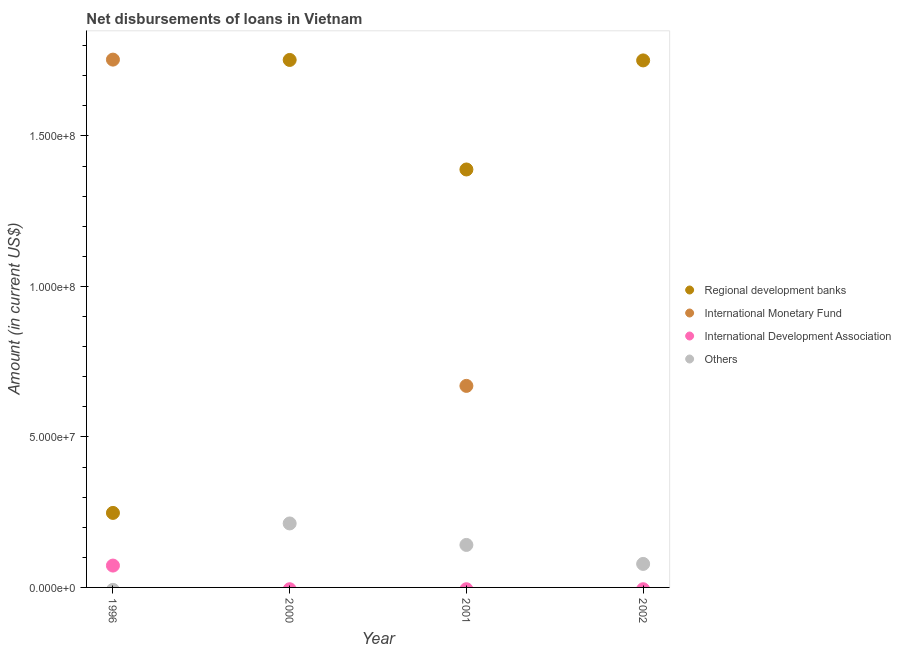How many different coloured dotlines are there?
Offer a very short reply. 4. Is the number of dotlines equal to the number of legend labels?
Give a very brief answer. No. What is the amount of loan disimbursed by international monetary fund in 2000?
Provide a short and direct response. 0. Across all years, what is the maximum amount of loan disimbursed by international monetary fund?
Ensure brevity in your answer.  1.75e+08. Across all years, what is the minimum amount of loan disimbursed by other organisations?
Ensure brevity in your answer.  0. What is the total amount of loan disimbursed by regional development banks in the graph?
Your answer should be compact. 5.14e+08. What is the difference between the amount of loan disimbursed by regional development banks in 1996 and that in 2000?
Offer a very short reply. -1.51e+08. What is the difference between the amount of loan disimbursed by international development association in 1996 and the amount of loan disimbursed by international monetary fund in 2000?
Keep it short and to the point. 7.26e+06. What is the average amount of loan disimbursed by international development association per year?
Keep it short and to the point. 1.82e+06. In the year 1996, what is the difference between the amount of loan disimbursed by regional development banks and amount of loan disimbursed by international development association?
Your response must be concise. 1.75e+07. What is the ratio of the amount of loan disimbursed by regional development banks in 2000 to that in 2002?
Ensure brevity in your answer.  1. Is the amount of loan disimbursed by regional development banks in 1996 less than that in 2001?
Your answer should be very brief. Yes. What is the difference between the highest and the second highest amount of loan disimbursed by regional development banks?
Offer a terse response. 1.56e+05. What is the difference between the highest and the lowest amount of loan disimbursed by other organisations?
Make the answer very short. 2.13e+07. In how many years, is the amount of loan disimbursed by other organisations greater than the average amount of loan disimbursed by other organisations taken over all years?
Your answer should be compact. 2. Is the sum of the amount of loan disimbursed by other organisations in 2001 and 2002 greater than the maximum amount of loan disimbursed by international development association across all years?
Provide a short and direct response. Yes. Is the amount of loan disimbursed by international monetary fund strictly greater than the amount of loan disimbursed by international development association over the years?
Your response must be concise. No. Is the amount of loan disimbursed by regional development banks strictly less than the amount of loan disimbursed by international monetary fund over the years?
Your answer should be compact. No. What is the difference between two consecutive major ticks on the Y-axis?
Ensure brevity in your answer.  5.00e+07. Does the graph contain any zero values?
Provide a succinct answer. Yes. Where does the legend appear in the graph?
Give a very brief answer. Center right. How are the legend labels stacked?
Ensure brevity in your answer.  Vertical. What is the title of the graph?
Make the answer very short. Net disbursements of loans in Vietnam. Does "Oil" appear as one of the legend labels in the graph?
Keep it short and to the point. No. What is the label or title of the X-axis?
Provide a succinct answer. Year. What is the label or title of the Y-axis?
Provide a short and direct response. Amount (in current US$). What is the Amount (in current US$) of Regional development banks in 1996?
Your answer should be very brief. 2.48e+07. What is the Amount (in current US$) of International Monetary Fund in 1996?
Your response must be concise. 1.75e+08. What is the Amount (in current US$) in International Development Association in 1996?
Your response must be concise. 7.26e+06. What is the Amount (in current US$) in Regional development banks in 2000?
Your answer should be very brief. 1.75e+08. What is the Amount (in current US$) of Others in 2000?
Ensure brevity in your answer.  2.13e+07. What is the Amount (in current US$) in Regional development banks in 2001?
Keep it short and to the point. 1.39e+08. What is the Amount (in current US$) of International Monetary Fund in 2001?
Your answer should be compact. 6.70e+07. What is the Amount (in current US$) of Others in 2001?
Provide a short and direct response. 1.41e+07. What is the Amount (in current US$) of Regional development banks in 2002?
Offer a terse response. 1.75e+08. What is the Amount (in current US$) of Others in 2002?
Ensure brevity in your answer.  7.81e+06. Across all years, what is the maximum Amount (in current US$) of Regional development banks?
Provide a short and direct response. 1.75e+08. Across all years, what is the maximum Amount (in current US$) in International Monetary Fund?
Your answer should be compact. 1.75e+08. Across all years, what is the maximum Amount (in current US$) of International Development Association?
Provide a short and direct response. 7.26e+06. Across all years, what is the maximum Amount (in current US$) in Others?
Your answer should be compact. 2.13e+07. Across all years, what is the minimum Amount (in current US$) of Regional development banks?
Give a very brief answer. 2.48e+07. Across all years, what is the minimum Amount (in current US$) of International Monetary Fund?
Keep it short and to the point. 0. What is the total Amount (in current US$) in Regional development banks in the graph?
Your answer should be compact. 5.14e+08. What is the total Amount (in current US$) of International Monetary Fund in the graph?
Your answer should be compact. 2.42e+08. What is the total Amount (in current US$) in International Development Association in the graph?
Make the answer very short. 7.26e+06. What is the total Amount (in current US$) in Others in the graph?
Your answer should be very brief. 4.32e+07. What is the difference between the Amount (in current US$) in Regional development banks in 1996 and that in 2000?
Ensure brevity in your answer.  -1.51e+08. What is the difference between the Amount (in current US$) of Regional development banks in 1996 and that in 2001?
Provide a succinct answer. -1.14e+08. What is the difference between the Amount (in current US$) of International Monetary Fund in 1996 and that in 2001?
Ensure brevity in your answer.  1.08e+08. What is the difference between the Amount (in current US$) of Regional development banks in 1996 and that in 2002?
Offer a very short reply. -1.50e+08. What is the difference between the Amount (in current US$) of Regional development banks in 2000 and that in 2001?
Make the answer very short. 3.64e+07. What is the difference between the Amount (in current US$) in Others in 2000 and that in 2001?
Your answer should be very brief. 7.14e+06. What is the difference between the Amount (in current US$) in Regional development banks in 2000 and that in 2002?
Offer a very short reply. 1.56e+05. What is the difference between the Amount (in current US$) of Others in 2000 and that in 2002?
Provide a short and direct response. 1.35e+07. What is the difference between the Amount (in current US$) of Regional development banks in 2001 and that in 2002?
Make the answer very short. -3.62e+07. What is the difference between the Amount (in current US$) in Others in 2001 and that in 2002?
Your answer should be compact. 6.31e+06. What is the difference between the Amount (in current US$) in Regional development banks in 1996 and the Amount (in current US$) in Others in 2000?
Your answer should be very brief. 3.50e+06. What is the difference between the Amount (in current US$) in International Monetary Fund in 1996 and the Amount (in current US$) in Others in 2000?
Your answer should be compact. 1.54e+08. What is the difference between the Amount (in current US$) of International Development Association in 1996 and the Amount (in current US$) of Others in 2000?
Provide a succinct answer. -1.40e+07. What is the difference between the Amount (in current US$) in Regional development banks in 1996 and the Amount (in current US$) in International Monetary Fund in 2001?
Offer a terse response. -4.22e+07. What is the difference between the Amount (in current US$) of Regional development banks in 1996 and the Amount (in current US$) of Others in 2001?
Provide a succinct answer. 1.06e+07. What is the difference between the Amount (in current US$) in International Monetary Fund in 1996 and the Amount (in current US$) in Others in 2001?
Ensure brevity in your answer.  1.61e+08. What is the difference between the Amount (in current US$) in International Development Association in 1996 and the Amount (in current US$) in Others in 2001?
Make the answer very short. -6.86e+06. What is the difference between the Amount (in current US$) of Regional development banks in 1996 and the Amount (in current US$) of Others in 2002?
Give a very brief answer. 1.69e+07. What is the difference between the Amount (in current US$) in International Monetary Fund in 1996 and the Amount (in current US$) in Others in 2002?
Ensure brevity in your answer.  1.68e+08. What is the difference between the Amount (in current US$) in International Development Association in 1996 and the Amount (in current US$) in Others in 2002?
Make the answer very short. -5.50e+05. What is the difference between the Amount (in current US$) of Regional development banks in 2000 and the Amount (in current US$) of International Monetary Fund in 2001?
Make the answer very short. 1.08e+08. What is the difference between the Amount (in current US$) of Regional development banks in 2000 and the Amount (in current US$) of Others in 2001?
Make the answer very short. 1.61e+08. What is the difference between the Amount (in current US$) of Regional development banks in 2000 and the Amount (in current US$) of Others in 2002?
Give a very brief answer. 1.67e+08. What is the difference between the Amount (in current US$) in Regional development banks in 2001 and the Amount (in current US$) in Others in 2002?
Your answer should be compact. 1.31e+08. What is the difference between the Amount (in current US$) of International Monetary Fund in 2001 and the Amount (in current US$) of Others in 2002?
Give a very brief answer. 5.92e+07. What is the average Amount (in current US$) of Regional development banks per year?
Ensure brevity in your answer.  1.29e+08. What is the average Amount (in current US$) of International Monetary Fund per year?
Offer a terse response. 6.06e+07. What is the average Amount (in current US$) in International Development Association per year?
Offer a terse response. 1.82e+06. What is the average Amount (in current US$) of Others per year?
Your answer should be compact. 1.08e+07. In the year 1996, what is the difference between the Amount (in current US$) in Regional development banks and Amount (in current US$) in International Monetary Fund?
Keep it short and to the point. -1.51e+08. In the year 1996, what is the difference between the Amount (in current US$) in Regional development banks and Amount (in current US$) in International Development Association?
Your answer should be very brief. 1.75e+07. In the year 1996, what is the difference between the Amount (in current US$) of International Monetary Fund and Amount (in current US$) of International Development Association?
Your response must be concise. 1.68e+08. In the year 2000, what is the difference between the Amount (in current US$) in Regional development banks and Amount (in current US$) in Others?
Your answer should be very brief. 1.54e+08. In the year 2001, what is the difference between the Amount (in current US$) in Regional development banks and Amount (in current US$) in International Monetary Fund?
Offer a terse response. 7.19e+07. In the year 2001, what is the difference between the Amount (in current US$) of Regional development banks and Amount (in current US$) of Others?
Offer a very short reply. 1.25e+08. In the year 2001, what is the difference between the Amount (in current US$) in International Monetary Fund and Amount (in current US$) in Others?
Keep it short and to the point. 5.28e+07. In the year 2002, what is the difference between the Amount (in current US$) of Regional development banks and Amount (in current US$) of Others?
Give a very brief answer. 1.67e+08. What is the ratio of the Amount (in current US$) in Regional development banks in 1996 to that in 2000?
Your answer should be compact. 0.14. What is the ratio of the Amount (in current US$) of Regional development banks in 1996 to that in 2001?
Offer a very short reply. 0.18. What is the ratio of the Amount (in current US$) in International Monetary Fund in 1996 to that in 2001?
Ensure brevity in your answer.  2.62. What is the ratio of the Amount (in current US$) of Regional development banks in 1996 to that in 2002?
Ensure brevity in your answer.  0.14. What is the ratio of the Amount (in current US$) of Regional development banks in 2000 to that in 2001?
Provide a succinct answer. 1.26. What is the ratio of the Amount (in current US$) of Others in 2000 to that in 2001?
Your answer should be very brief. 1.51. What is the ratio of the Amount (in current US$) in Others in 2000 to that in 2002?
Your response must be concise. 2.72. What is the ratio of the Amount (in current US$) in Regional development banks in 2001 to that in 2002?
Your answer should be compact. 0.79. What is the ratio of the Amount (in current US$) of Others in 2001 to that in 2002?
Offer a very short reply. 1.81. What is the difference between the highest and the second highest Amount (in current US$) of Regional development banks?
Ensure brevity in your answer.  1.56e+05. What is the difference between the highest and the second highest Amount (in current US$) in Others?
Your answer should be very brief. 7.14e+06. What is the difference between the highest and the lowest Amount (in current US$) of Regional development banks?
Offer a very short reply. 1.51e+08. What is the difference between the highest and the lowest Amount (in current US$) of International Monetary Fund?
Make the answer very short. 1.75e+08. What is the difference between the highest and the lowest Amount (in current US$) in International Development Association?
Make the answer very short. 7.26e+06. What is the difference between the highest and the lowest Amount (in current US$) of Others?
Offer a very short reply. 2.13e+07. 